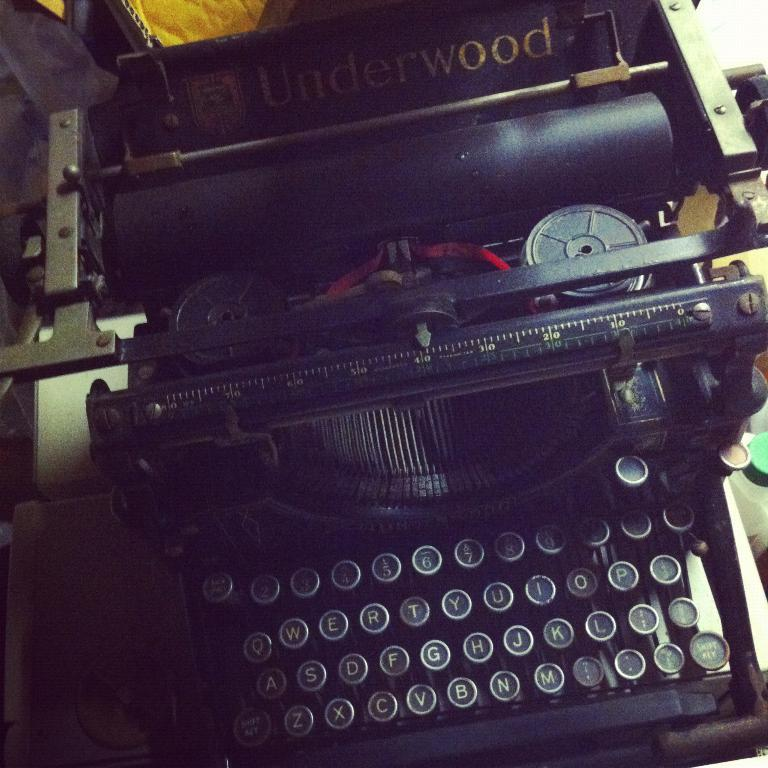<image>
Describe the image concisely. A black old typewriter made by the brand Underwood. 